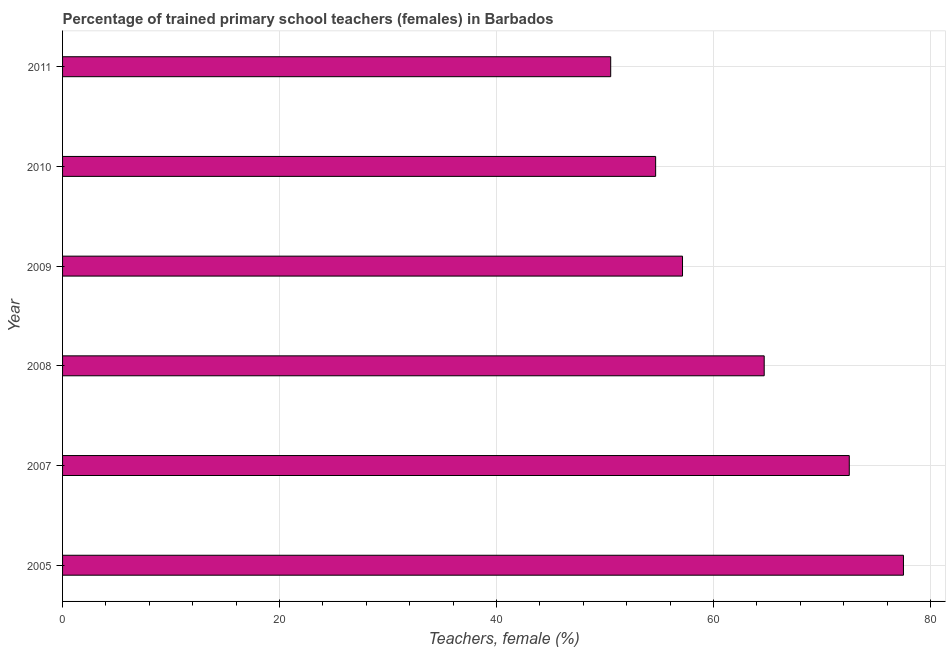Does the graph contain grids?
Your response must be concise. Yes. What is the title of the graph?
Your response must be concise. Percentage of trained primary school teachers (females) in Barbados. What is the label or title of the X-axis?
Give a very brief answer. Teachers, female (%). What is the percentage of trained female teachers in 2010?
Offer a terse response. 54.67. Across all years, what is the maximum percentage of trained female teachers?
Make the answer very short. 77.51. Across all years, what is the minimum percentage of trained female teachers?
Provide a succinct answer. 50.52. In which year was the percentage of trained female teachers maximum?
Your answer should be compact. 2005. In which year was the percentage of trained female teachers minimum?
Provide a short and direct response. 2011. What is the sum of the percentage of trained female teachers?
Keep it short and to the point. 377.03. What is the difference between the percentage of trained female teachers in 2008 and 2011?
Keep it short and to the point. 14.15. What is the average percentage of trained female teachers per year?
Provide a succinct answer. 62.84. What is the median percentage of trained female teachers?
Keep it short and to the point. 60.91. What is the ratio of the percentage of trained female teachers in 2005 to that in 2010?
Your response must be concise. 1.42. Is the percentage of trained female teachers in 2009 less than that in 2011?
Provide a short and direct response. No. Is the difference between the percentage of trained female teachers in 2007 and 2011 greater than the difference between any two years?
Give a very brief answer. No. What is the difference between the highest and the second highest percentage of trained female teachers?
Provide a succinct answer. 4.99. What is the difference between the highest and the lowest percentage of trained female teachers?
Offer a very short reply. 26.98. Are all the bars in the graph horizontal?
Ensure brevity in your answer.  Yes. What is the difference between two consecutive major ticks on the X-axis?
Your response must be concise. 20. What is the Teachers, female (%) in 2005?
Keep it short and to the point. 77.51. What is the Teachers, female (%) in 2007?
Your answer should be compact. 72.51. What is the Teachers, female (%) in 2008?
Provide a succinct answer. 64.67. What is the Teachers, female (%) in 2009?
Offer a very short reply. 57.14. What is the Teachers, female (%) of 2010?
Give a very brief answer. 54.67. What is the Teachers, female (%) in 2011?
Keep it short and to the point. 50.52. What is the difference between the Teachers, female (%) in 2005 and 2007?
Your answer should be very brief. 4.99. What is the difference between the Teachers, female (%) in 2005 and 2008?
Keep it short and to the point. 12.84. What is the difference between the Teachers, female (%) in 2005 and 2009?
Provide a short and direct response. 20.36. What is the difference between the Teachers, female (%) in 2005 and 2010?
Your answer should be very brief. 22.84. What is the difference between the Teachers, female (%) in 2005 and 2011?
Provide a short and direct response. 26.98. What is the difference between the Teachers, female (%) in 2007 and 2008?
Provide a short and direct response. 7.84. What is the difference between the Teachers, female (%) in 2007 and 2009?
Provide a short and direct response. 15.37. What is the difference between the Teachers, female (%) in 2007 and 2010?
Ensure brevity in your answer.  17.85. What is the difference between the Teachers, female (%) in 2007 and 2011?
Your answer should be very brief. 21.99. What is the difference between the Teachers, female (%) in 2008 and 2009?
Provide a short and direct response. 7.53. What is the difference between the Teachers, female (%) in 2008 and 2010?
Provide a succinct answer. 10.01. What is the difference between the Teachers, female (%) in 2008 and 2011?
Your answer should be very brief. 14.15. What is the difference between the Teachers, female (%) in 2009 and 2010?
Offer a very short reply. 2.48. What is the difference between the Teachers, female (%) in 2009 and 2011?
Your answer should be very brief. 6.62. What is the difference between the Teachers, female (%) in 2010 and 2011?
Offer a terse response. 4.14. What is the ratio of the Teachers, female (%) in 2005 to that in 2007?
Your response must be concise. 1.07. What is the ratio of the Teachers, female (%) in 2005 to that in 2008?
Give a very brief answer. 1.2. What is the ratio of the Teachers, female (%) in 2005 to that in 2009?
Make the answer very short. 1.36. What is the ratio of the Teachers, female (%) in 2005 to that in 2010?
Your answer should be compact. 1.42. What is the ratio of the Teachers, female (%) in 2005 to that in 2011?
Keep it short and to the point. 1.53. What is the ratio of the Teachers, female (%) in 2007 to that in 2008?
Ensure brevity in your answer.  1.12. What is the ratio of the Teachers, female (%) in 2007 to that in 2009?
Make the answer very short. 1.27. What is the ratio of the Teachers, female (%) in 2007 to that in 2010?
Your answer should be compact. 1.33. What is the ratio of the Teachers, female (%) in 2007 to that in 2011?
Your response must be concise. 1.44. What is the ratio of the Teachers, female (%) in 2008 to that in 2009?
Your answer should be very brief. 1.13. What is the ratio of the Teachers, female (%) in 2008 to that in 2010?
Offer a very short reply. 1.18. What is the ratio of the Teachers, female (%) in 2008 to that in 2011?
Make the answer very short. 1.28. What is the ratio of the Teachers, female (%) in 2009 to that in 2010?
Offer a very short reply. 1.04. What is the ratio of the Teachers, female (%) in 2009 to that in 2011?
Provide a short and direct response. 1.13. What is the ratio of the Teachers, female (%) in 2010 to that in 2011?
Ensure brevity in your answer.  1.08. 